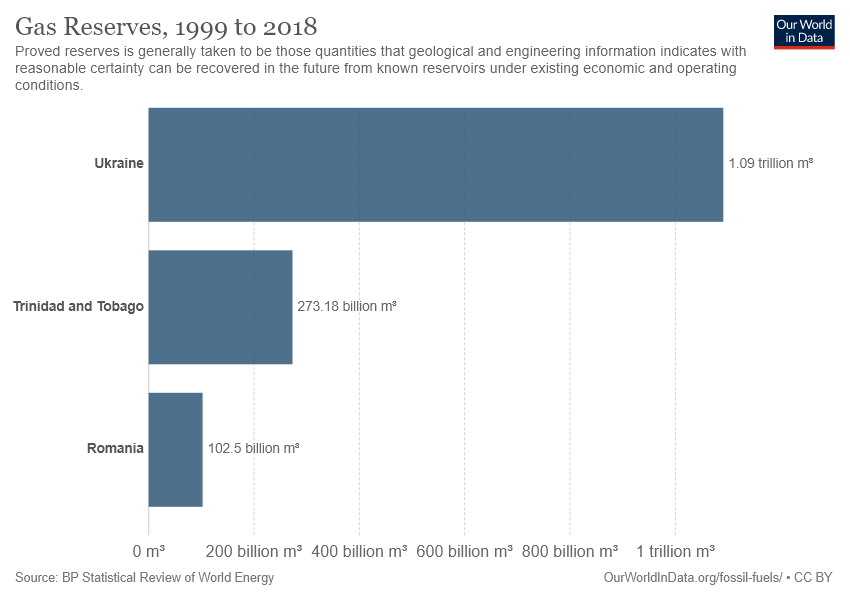Outline some significant characteristics in this image. Trinidad and Tobago has gas reserves that are more than Romania but less than Ukraine. The total value of gas reserves in Romania and Trinidad and Tobago is more than 350 billion m3, and it is true. 